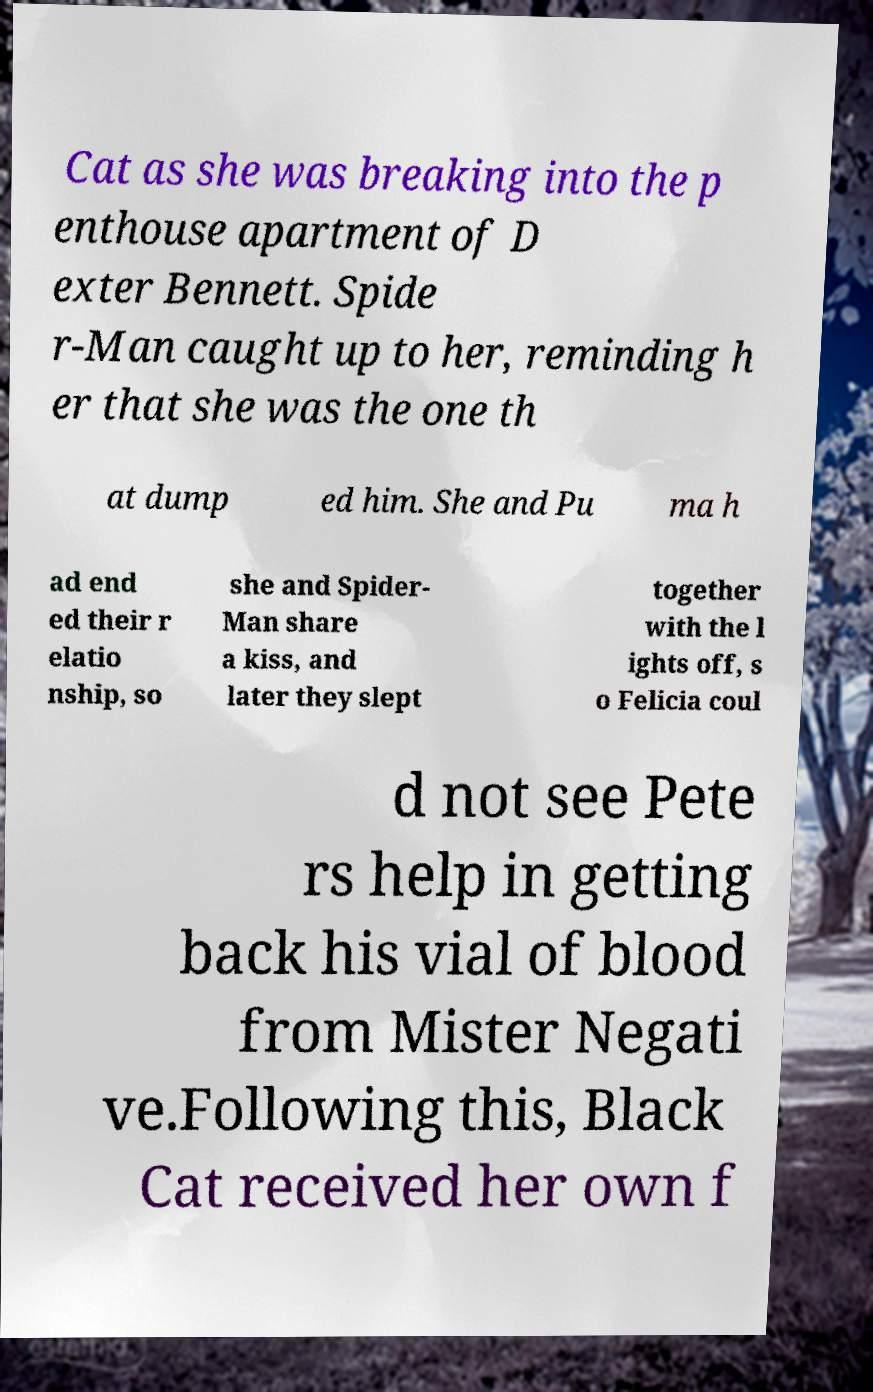Please read and relay the text visible in this image. What does it say? Cat as she was breaking into the p enthouse apartment of D exter Bennett. Spide r-Man caught up to her, reminding h er that she was the one th at dump ed him. She and Pu ma h ad end ed their r elatio nship, so she and Spider- Man share a kiss, and later they slept together with the l ights off, s o Felicia coul d not see Pete rs help in getting back his vial of blood from Mister Negati ve.Following this, Black Cat received her own f 